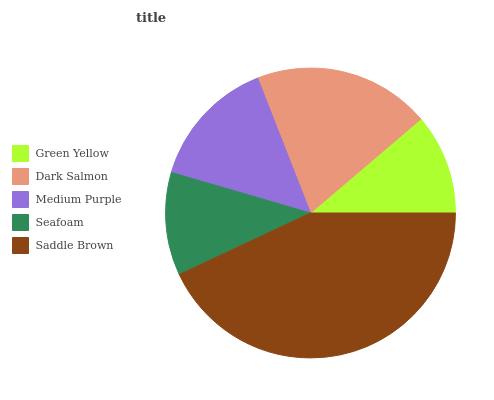Is Green Yellow the minimum?
Answer yes or no. Yes. Is Saddle Brown the maximum?
Answer yes or no. Yes. Is Dark Salmon the minimum?
Answer yes or no. No. Is Dark Salmon the maximum?
Answer yes or no. No. Is Dark Salmon greater than Green Yellow?
Answer yes or no. Yes. Is Green Yellow less than Dark Salmon?
Answer yes or no. Yes. Is Green Yellow greater than Dark Salmon?
Answer yes or no. No. Is Dark Salmon less than Green Yellow?
Answer yes or no. No. Is Medium Purple the high median?
Answer yes or no. Yes. Is Medium Purple the low median?
Answer yes or no. Yes. Is Green Yellow the high median?
Answer yes or no. No. Is Seafoam the low median?
Answer yes or no. No. 